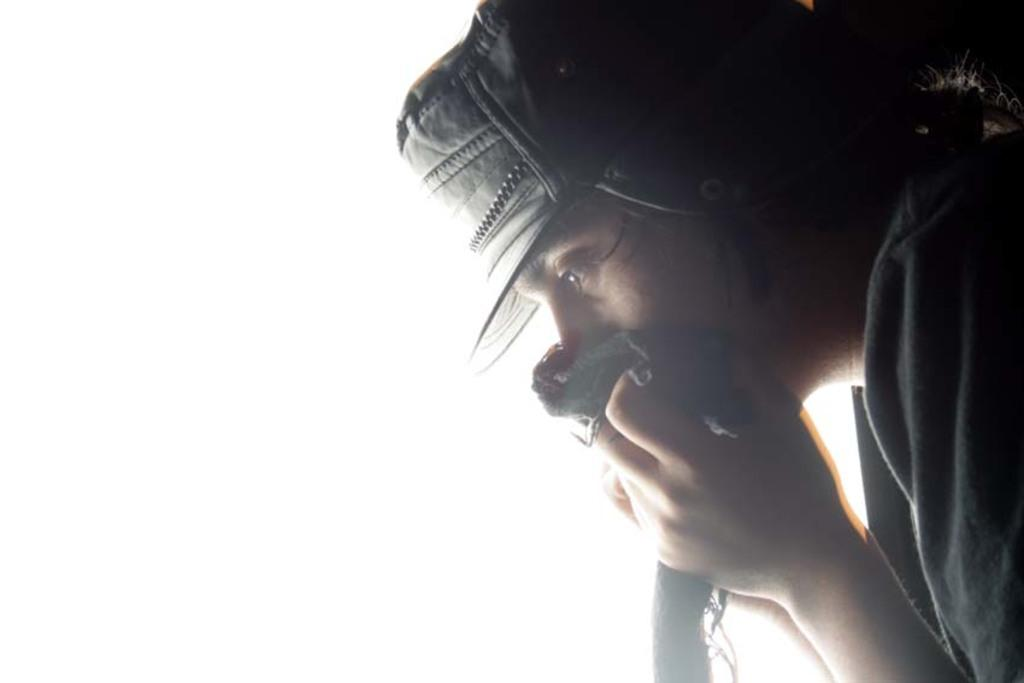What is the main subject of the image? There is a person in the image. Can you describe the person's attire? The person is wearing a cap. What object is the person holding? The person is holding a mask. Where is the sink located in the image? There is no sink present in the image. How does the baby contribute to the invention in the image? There is no baby or invention present in the image. 